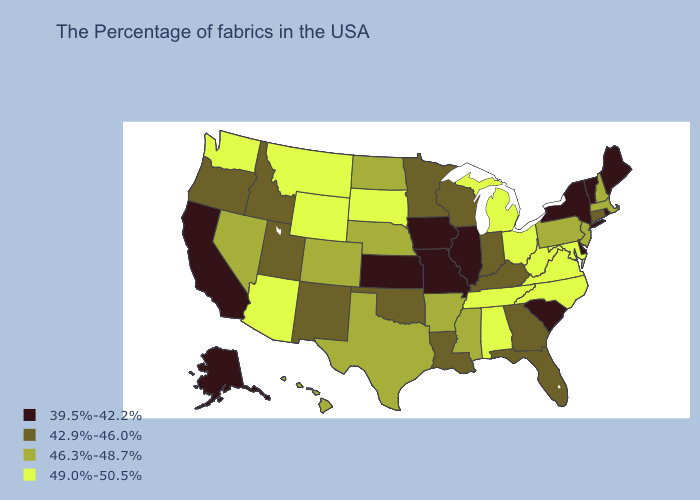Among the states that border Arkansas , which have the highest value?
Give a very brief answer. Tennessee. What is the value of Kansas?
Quick response, please. 39.5%-42.2%. Does Rhode Island have the lowest value in the Northeast?
Give a very brief answer. Yes. What is the value of Washington?
Write a very short answer. 49.0%-50.5%. Which states have the highest value in the USA?
Write a very short answer. Maryland, Virginia, North Carolina, West Virginia, Ohio, Michigan, Alabama, Tennessee, South Dakota, Wyoming, Montana, Arizona, Washington. Does the first symbol in the legend represent the smallest category?
Write a very short answer. Yes. Among the states that border Michigan , does Indiana have the highest value?
Answer briefly. No. Name the states that have a value in the range 49.0%-50.5%?
Answer briefly. Maryland, Virginia, North Carolina, West Virginia, Ohio, Michigan, Alabama, Tennessee, South Dakota, Wyoming, Montana, Arizona, Washington. Name the states that have a value in the range 39.5%-42.2%?
Give a very brief answer. Maine, Rhode Island, Vermont, New York, Delaware, South Carolina, Illinois, Missouri, Iowa, Kansas, California, Alaska. Which states have the lowest value in the USA?
Keep it brief. Maine, Rhode Island, Vermont, New York, Delaware, South Carolina, Illinois, Missouri, Iowa, Kansas, California, Alaska. Name the states that have a value in the range 46.3%-48.7%?
Give a very brief answer. Massachusetts, New Hampshire, New Jersey, Pennsylvania, Mississippi, Arkansas, Nebraska, Texas, North Dakota, Colorado, Nevada, Hawaii. Name the states that have a value in the range 42.9%-46.0%?
Give a very brief answer. Connecticut, Florida, Georgia, Kentucky, Indiana, Wisconsin, Louisiana, Minnesota, Oklahoma, New Mexico, Utah, Idaho, Oregon. Name the states that have a value in the range 49.0%-50.5%?
Write a very short answer. Maryland, Virginia, North Carolina, West Virginia, Ohio, Michigan, Alabama, Tennessee, South Dakota, Wyoming, Montana, Arizona, Washington. Name the states that have a value in the range 46.3%-48.7%?
Give a very brief answer. Massachusetts, New Hampshire, New Jersey, Pennsylvania, Mississippi, Arkansas, Nebraska, Texas, North Dakota, Colorado, Nevada, Hawaii. Among the states that border New York , which have the highest value?
Concise answer only. Massachusetts, New Jersey, Pennsylvania. 